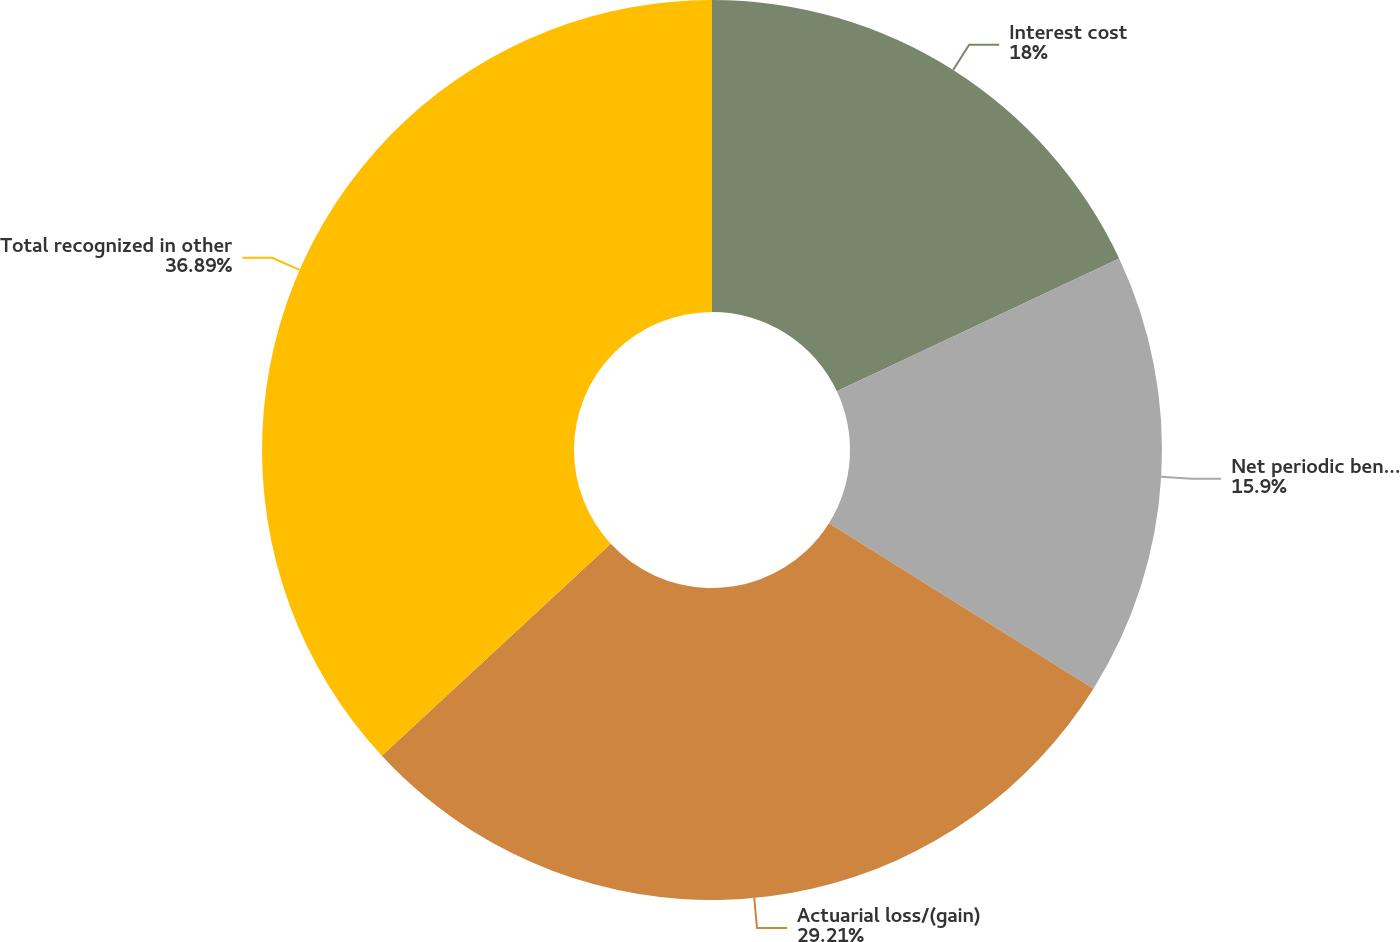<chart> <loc_0><loc_0><loc_500><loc_500><pie_chart><fcel>Interest cost<fcel>Net periodic benefit cost<fcel>Actuarial loss/(gain)<fcel>Total recognized in other<nl><fcel>18.0%<fcel>15.9%<fcel>29.21%<fcel>36.89%<nl></chart> 